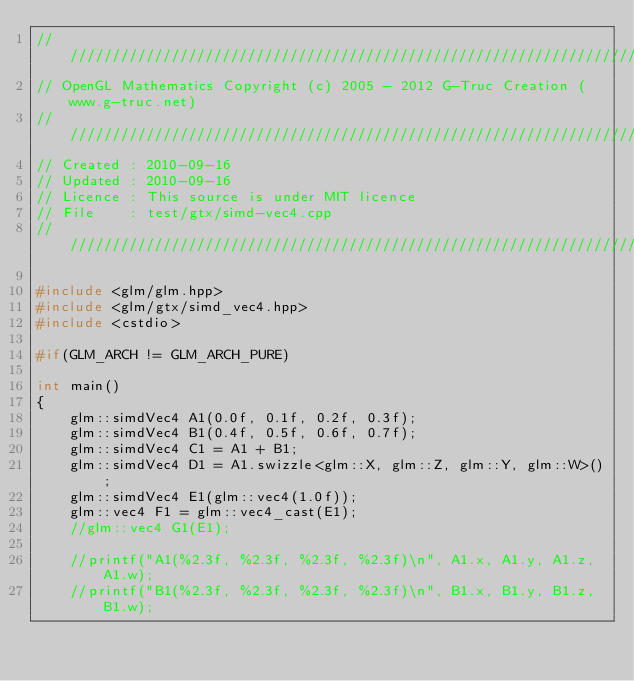Convert code to text. <code><loc_0><loc_0><loc_500><loc_500><_C++_>///////////////////////////////////////////////////////////////////////////////////////////////////
// OpenGL Mathematics Copyright (c) 2005 - 2012 G-Truc Creation (www.g-truc.net)
///////////////////////////////////////////////////////////////////////////////////////////////////
// Created : 2010-09-16
// Updated : 2010-09-16
// Licence : This source is under MIT licence
// File    : test/gtx/simd-vec4.cpp
///////////////////////////////////////////////////////////////////////////////////////////////////

#include <glm/glm.hpp>
#include <glm/gtx/simd_vec4.hpp>
#include <cstdio>

#if(GLM_ARCH != GLM_ARCH_PURE)

int main()
{
	glm::simdVec4 A1(0.0f, 0.1f, 0.2f, 0.3f);
	glm::simdVec4 B1(0.4f, 0.5f, 0.6f, 0.7f);
	glm::simdVec4 C1 = A1 + B1;
	glm::simdVec4 D1 = A1.swizzle<glm::X, glm::Z, glm::Y, glm::W>();
	glm::simdVec4 E1(glm::vec4(1.0f));
	glm::vec4 F1 = glm::vec4_cast(E1);
	//glm::vec4 G1(E1);

	//printf("A1(%2.3f, %2.3f, %2.3f, %2.3f)\n", A1.x, A1.y, A1.z, A1.w);
	//printf("B1(%2.3f, %2.3f, %2.3f, %2.3f)\n", B1.x, B1.y, B1.z, B1.w);</code> 